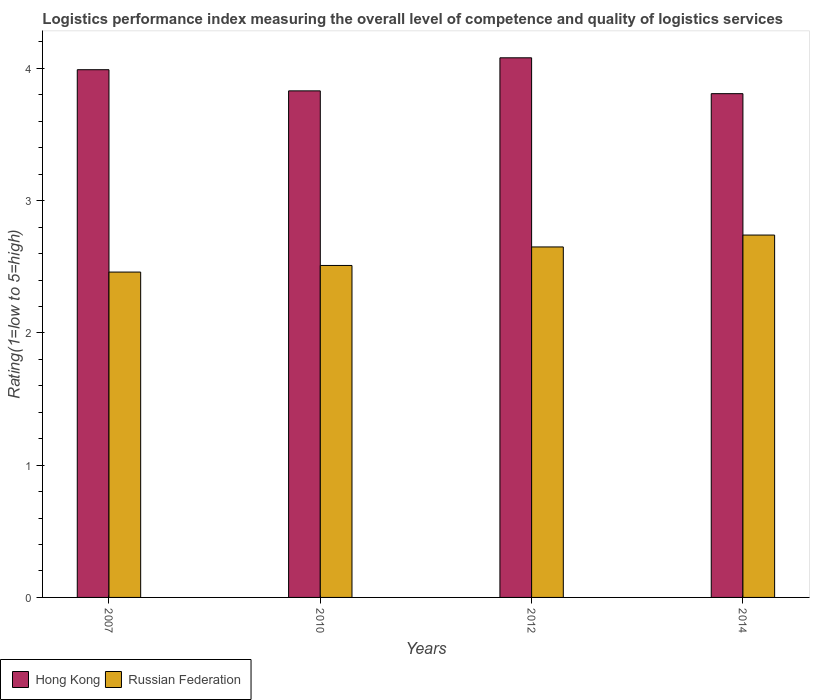Are the number of bars on each tick of the X-axis equal?
Give a very brief answer. Yes. What is the label of the 2nd group of bars from the left?
Offer a terse response. 2010. What is the Logistic performance index in Hong Kong in 2007?
Your answer should be compact. 3.99. Across all years, what is the maximum Logistic performance index in Hong Kong?
Give a very brief answer. 4.08. Across all years, what is the minimum Logistic performance index in Russian Federation?
Provide a succinct answer. 2.46. What is the total Logistic performance index in Russian Federation in the graph?
Your response must be concise. 10.36. What is the difference between the Logistic performance index in Hong Kong in 2007 and that in 2012?
Offer a terse response. -0.09. What is the difference between the Logistic performance index in Russian Federation in 2007 and the Logistic performance index in Hong Kong in 2012?
Provide a short and direct response. -1.62. What is the average Logistic performance index in Russian Federation per year?
Keep it short and to the point. 2.59. In the year 2014, what is the difference between the Logistic performance index in Hong Kong and Logistic performance index in Russian Federation?
Give a very brief answer. 1.07. What is the ratio of the Logistic performance index in Hong Kong in 2012 to that in 2014?
Keep it short and to the point. 1.07. Is the difference between the Logistic performance index in Hong Kong in 2010 and 2014 greater than the difference between the Logistic performance index in Russian Federation in 2010 and 2014?
Provide a succinct answer. Yes. What is the difference between the highest and the second highest Logistic performance index in Hong Kong?
Provide a succinct answer. 0.09. What is the difference between the highest and the lowest Logistic performance index in Russian Federation?
Offer a very short reply. 0.28. Is the sum of the Logistic performance index in Russian Federation in 2007 and 2014 greater than the maximum Logistic performance index in Hong Kong across all years?
Your response must be concise. Yes. What does the 2nd bar from the left in 2014 represents?
Provide a succinct answer. Russian Federation. What does the 2nd bar from the right in 2014 represents?
Provide a short and direct response. Hong Kong. Does the graph contain grids?
Your answer should be very brief. No. What is the title of the graph?
Your answer should be very brief. Logistics performance index measuring the overall level of competence and quality of logistics services. Does "Zimbabwe" appear as one of the legend labels in the graph?
Ensure brevity in your answer.  No. What is the label or title of the X-axis?
Offer a very short reply. Years. What is the label or title of the Y-axis?
Offer a very short reply. Rating(1=low to 5=high). What is the Rating(1=low to 5=high) of Hong Kong in 2007?
Provide a short and direct response. 3.99. What is the Rating(1=low to 5=high) in Russian Federation in 2007?
Your response must be concise. 2.46. What is the Rating(1=low to 5=high) in Hong Kong in 2010?
Your answer should be very brief. 3.83. What is the Rating(1=low to 5=high) in Russian Federation in 2010?
Ensure brevity in your answer.  2.51. What is the Rating(1=low to 5=high) of Hong Kong in 2012?
Make the answer very short. 4.08. What is the Rating(1=low to 5=high) of Russian Federation in 2012?
Your response must be concise. 2.65. What is the Rating(1=low to 5=high) in Hong Kong in 2014?
Provide a succinct answer. 3.81. What is the Rating(1=low to 5=high) of Russian Federation in 2014?
Your answer should be compact. 2.74. Across all years, what is the maximum Rating(1=low to 5=high) of Hong Kong?
Provide a short and direct response. 4.08. Across all years, what is the maximum Rating(1=low to 5=high) in Russian Federation?
Your response must be concise. 2.74. Across all years, what is the minimum Rating(1=low to 5=high) in Hong Kong?
Provide a short and direct response. 3.81. Across all years, what is the minimum Rating(1=low to 5=high) in Russian Federation?
Ensure brevity in your answer.  2.46. What is the total Rating(1=low to 5=high) of Hong Kong in the graph?
Your answer should be compact. 15.71. What is the total Rating(1=low to 5=high) of Russian Federation in the graph?
Offer a terse response. 10.36. What is the difference between the Rating(1=low to 5=high) of Hong Kong in 2007 and that in 2010?
Keep it short and to the point. 0.16. What is the difference between the Rating(1=low to 5=high) of Russian Federation in 2007 and that in 2010?
Offer a terse response. -0.05. What is the difference between the Rating(1=low to 5=high) in Hong Kong in 2007 and that in 2012?
Provide a short and direct response. -0.09. What is the difference between the Rating(1=low to 5=high) in Russian Federation in 2007 and that in 2012?
Make the answer very short. -0.19. What is the difference between the Rating(1=low to 5=high) in Hong Kong in 2007 and that in 2014?
Provide a succinct answer. 0.18. What is the difference between the Rating(1=low to 5=high) of Russian Federation in 2007 and that in 2014?
Provide a succinct answer. -0.28. What is the difference between the Rating(1=low to 5=high) of Russian Federation in 2010 and that in 2012?
Provide a succinct answer. -0.14. What is the difference between the Rating(1=low to 5=high) in Hong Kong in 2010 and that in 2014?
Give a very brief answer. 0.02. What is the difference between the Rating(1=low to 5=high) in Russian Federation in 2010 and that in 2014?
Provide a succinct answer. -0.23. What is the difference between the Rating(1=low to 5=high) of Hong Kong in 2012 and that in 2014?
Your answer should be very brief. 0.27. What is the difference between the Rating(1=low to 5=high) of Russian Federation in 2012 and that in 2014?
Make the answer very short. -0.09. What is the difference between the Rating(1=low to 5=high) of Hong Kong in 2007 and the Rating(1=low to 5=high) of Russian Federation in 2010?
Your response must be concise. 1.48. What is the difference between the Rating(1=low to 5=high) of Hong Kong in 2007 and the Rating(1=low to 5=high) of Russian Federation in 2012?
Offer a terse response. 1.34. What is the difference between the Rating(1=low to 5=high) in Hong Kong in 2007 and the Rating(1=low to 5=high) in Russian Federation in 2014?
Your answer should be compact. 1.25. What is the difference between the Rating(1=low to 5=high) in Hong Kong in 2010 and the Rating(1=low to 5=high) in Russian Federation in 2012?
Provide a short and direct response. 1.18. What is the difference between the Rating(1=low to 5=high) in Hong Kong in 2010 and the Rating(1=low to 5=high) in Russian Federation in 2014?
Provide a succinct answer. 1.09. What is the difference between the Rating(1=low to 5=high) of Hong Kong in 2012 and the Rating(1=low to 5=high) of Russian Federation in 2014?
Your answer should be compact. 1.34. What is the average Rating(1=low to 5=high) of Hong Kong per year?
Offer a terse response. 3.93. What is the average Rating(1=low to 5=high) of Russian Federation per year?
Make the answer very short. 2.59. In the year 2007, what is the difference between the Rating(1=low to 5=high) in Hong Kong and Rating(1=low to 5=high) in Russian Federation?
Your answer should be compact. 1.53. In the year 2010, what is the difference between the Rating(1=low to 5=high) in Hong Kong and Rating(1=low to 5=high) in Russian Federation?
Keep it short and to the point. 1.32. In the year 2012, what is the difference between the Rating(1=low to 5=high) in Hong Kong and Rating(1=low to 5=high) in Russian Federation?
Your answer should be very brief. 1.43. In the year 2014, what is the difference between the Rating(1=low to 5=high) in Hong Kong and Rating(1=low to 5=high) in Russian Federation?
Offer a very short reply. 1.07. What is the ratio of the Rating(1=low to 5=high) in Hong Kong in 2007 to that in 2010?
Offer a very short reply. 1.04. What is the ratio of the Rating(1=low to 5=high) in Russian Federation in 2007 to that in 2010?
Provide a short and direct response. 0.98. What is the ratio of the Rating(1=low to 5=high) in Hong Kong in 2007 to that in 2012?
Make the answer very short. 0.98. What is the ratio of the Rating(1=low to 5=high) of Russian Federation in 2007 to that in 2012?
Offer a terse response. 0.93. What is the ratio of the Rating(1=low to 5=high) in Hong Kong in 2007 to that in 2014?
Ensure brevity in your answer.  1.05. What is the ratio of the Rating(1=low to 5=high) in Russian Federation in 2007 to that in 2014?
Provide a short and direct response. 0.9. What is the ratio of the Rating(1=low to 5=high) of Hong Kong in 2010 to that in 2012?
Your answer should be compact. 0.94. What is the ratio of the Rating(1=low to 5=high) of Russian Federation in 2010 to that in 2012?
Your answer should be very brief. 0.95. What is the ratio of the Rating(1=low to 5=high) in Russian Federation in 2010 to that in 2014?
Your answer should be compact. 0.92. What is the ratio of the Rating(1=low to 5=high) in Hong Kong in 2012 to that in 2014?
Provide a short and direct response. 1.07. What is the ratio of the Rating(1=low to 5=high) in Russian Federation in 2012 to that in 2014?
Offer a terse response. 0.97. What is the difference between the highest and the second highest Rating(1=low to 5=high) in Hong Kong?
Provide a succinct answer. 0.09. What is the difference between the highest and the second highest Rating(1=low to 5=high) of Russian Federation?
Your answer should be very brief. 0.09. What is the difference between the highest and the lowest Rating(1=low to 5=high) of Hong Kong?
Offer a very short reply. 0.27. What is the difference between the highest and the lowest Rating(1=low to 5=high) in Russian Federation?
Offer a very short reply. 0.28. 